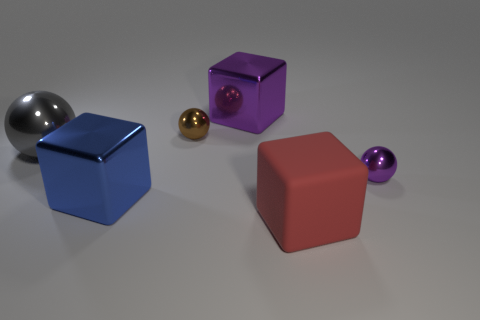There is a thing on the right side of the red thing; does it have the same size as the small brown metal object?
Give a very brief answer. Yes. What size is the blue cube that is made of the same material as the big gray sphere?
Keep it short and to the point. Large. Are there more metallic objects on the left side of the big blue object than shiny cubes that are in front of the big red thing?
Your response must be concise. Yes. How many other objects are the same material as the tiny purple thing?
Give a very brief answer. 4. Does the big object on the left side of the large blue object have the same material as the small purple sphere?
Give a very brief answer. Yes. What shape is the gray metal object?
Provide a short and direct response. Sphere. Is the number of metallic objects to the right of the large blue cube greater than the number of tiny green objects?
Make the answer very short. Yes. The other tiny object that is the same shape as the brown object is what color?
Provide a succinct answer. Purple. What is the shape of the blue thing on the right side of the gray sphere?
Make the answer very short. Cube. There is a blue metal thing; are there any small purple objects on the right side of it?
Your answer should be compact. Yes. 